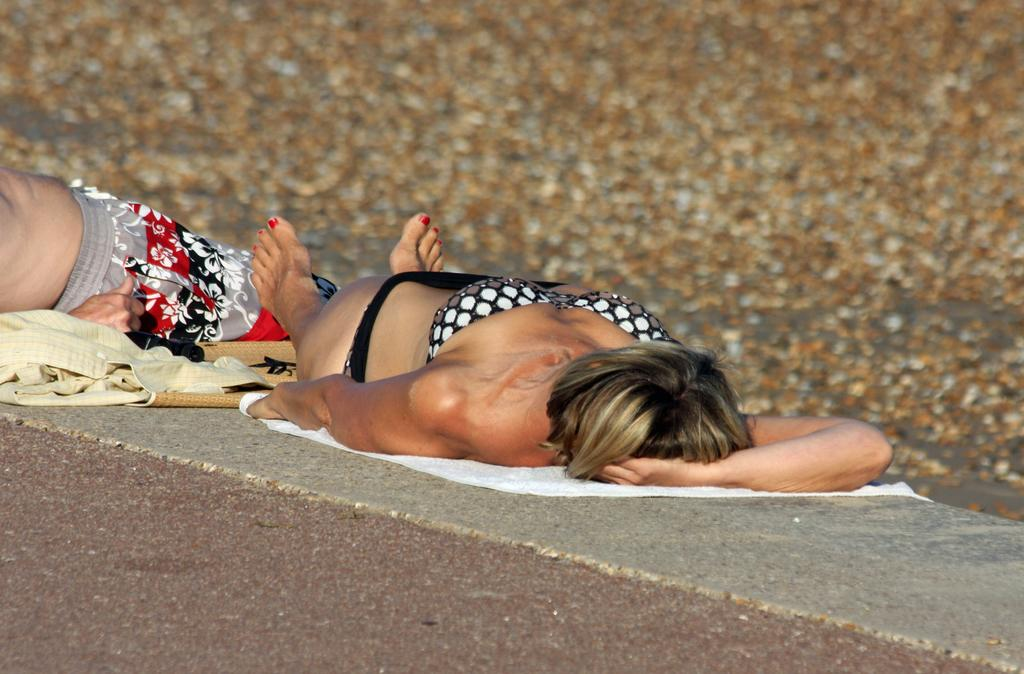Who are the people in the image? There is a woman and a man in the image. What are the positions of the woman and the man in the image? Both the woman and the man are lying down. What type of material is visible in the image? There is cloth visible in the image. What is the surface beneath the woman and the man in the image? There is a solid surface in the image. Can you describe the background of the image? The background of the image is blurred. How many quartz rocks can be seen in the image? There are no quartz rocks present in the image. What type of frogs are hopping around the woman and the man in the image? There are no frogs present in the image. 